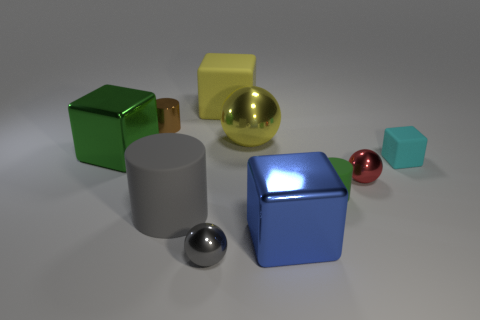Is the number of tiny blocks on the left side of the gray cylinder greater than the number of green cylinders on the left side of the big green shiny thing?
Provide a succinct answer. No. What number of other objects are there of the same size as the brown metal thing?
Your answer should be very brief. 4. There is a big matte thing that is behind the brown thing; is it the same color as the small block?
Keep it short and to the point. No. Is the number of matte cylinders that are in front of the small gray sphere greater than the number of tiny gray metal cubes?
Keep it short and to the point. No. Is there anything else that has the same color as the small cube?
Your answer should be very brief. No. The tiny rubber object that is right of the green object in front of the cyan rubber object is what shape?
Your answer should be compact. Cube. Is the number of large gray rubber objects greater than the number of objects?
Provide a succinct answer. No. How many rubber objects are in front of the big sphere and behind the tiny brown cylinder?
Your response must be concise. 0. There is a matte cylinder in front of the green rubber cylinder; what number of small red things are left of it?
Provide a succinct answer. 0. What number of things are big matte objects in front of the tiny metal cylinder or green objects that are left of the green cylinder?
Provide a succinct answer. 2. 